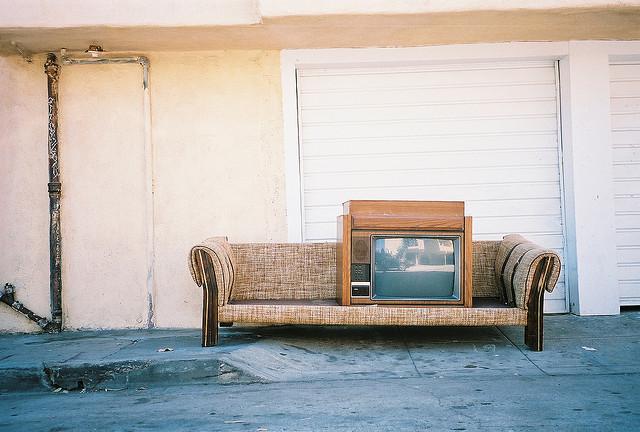What is sitting on the couch?
Quick response, please. Tv. Is the television on?
Be succinct. No. What color is the couch?
Write a very short answer. Brown. 